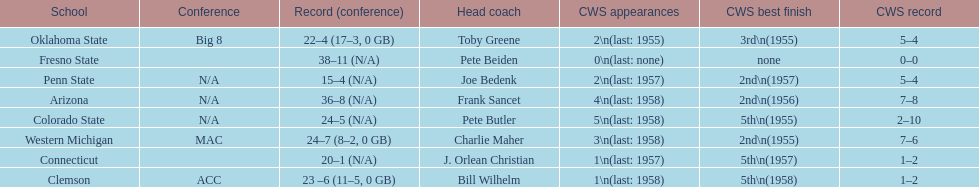Which team did not have more than 16 wins? Penn State. 